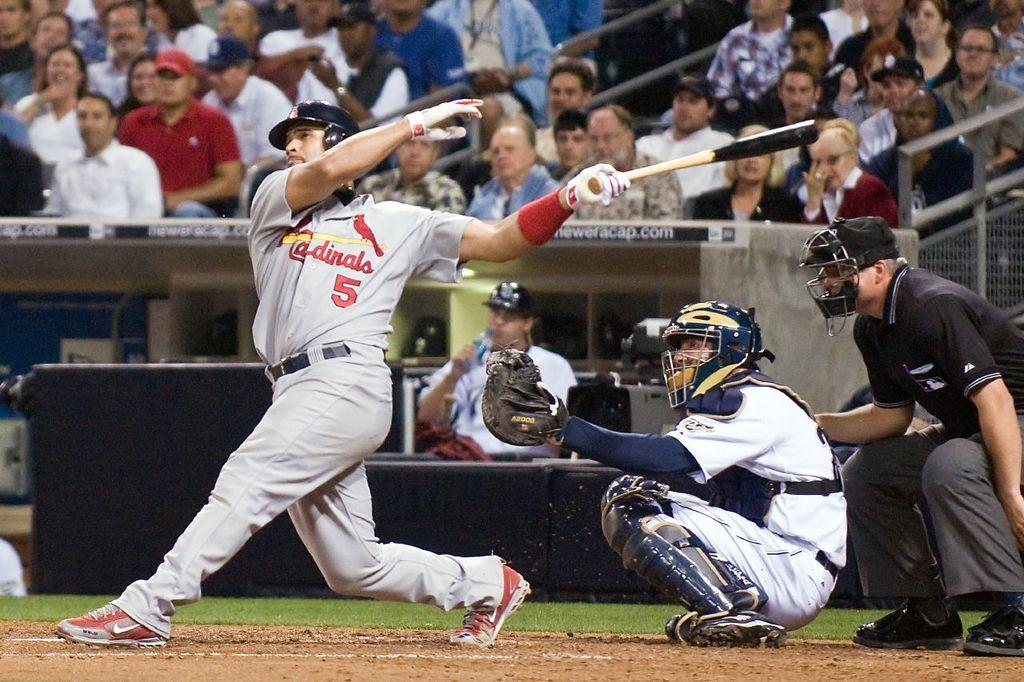<image>
Present a compact description of the photo's key features. Baseball player for the Cardinals hitting a baseball with the bat. 